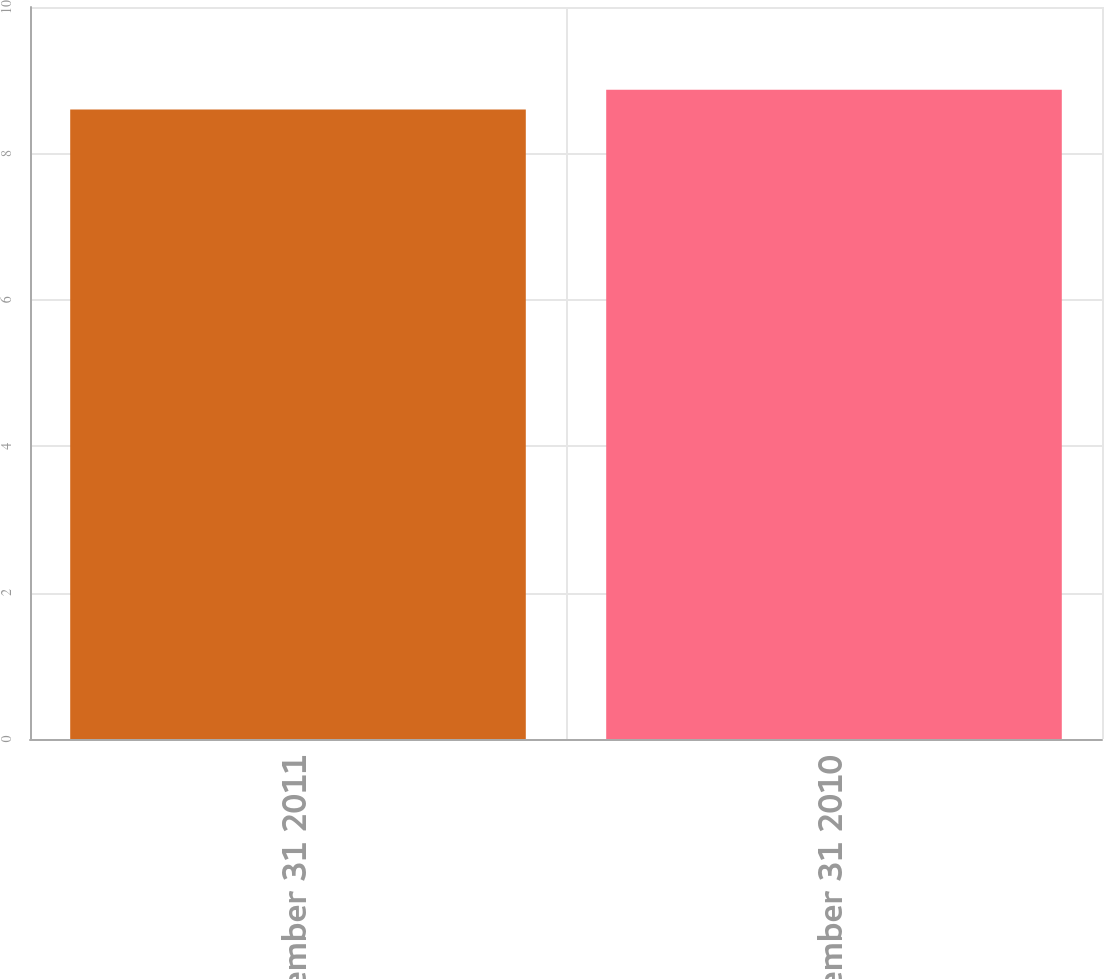Convert chart to OTSL. <chart><loc_0><loc_0><loc_500><loc_500><bar_chart><fcel>December 31 2011<fcel>December 31 2010<nl><fcel>8.6<fcel>8.87<nl></chart> 